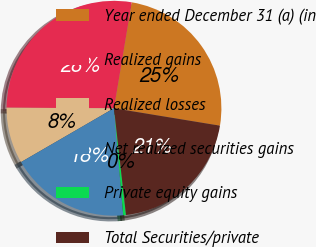<chart> <loc_0><loc_0><loc_500><loc_500><pie_chart><fcel>Year ended December 31 (a) (in<fcel>Realized gains<fcel>Realized losses<fcel>Net realized securities gains<fcel>Private equity gains<fcel>Total Securities/private<nl><fcel>24.96%<fcel>27.56%<fcel>8.44%<fcel>18.02%<fcel>0.41%<fcel>20.62%<nl></chart> 